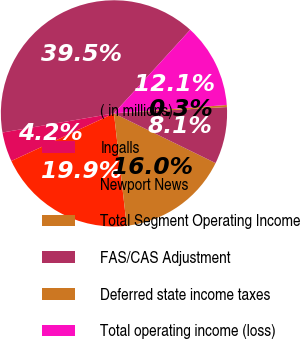Convert chart to OTSL. <chart><loc_0><loc_0><loc_500><loc_500><pie_chart><fcel>( in millions)<fcel>Ingalls<fcel>Newport News<fcel>Total Segment Operating Income<fcel>FAS/CAS Adjustment<fcel>Deferred state income taxes<fcel>Total operating income (loss)<nl><fcel>39.47%<fcel>4.21%<fcel>19.88%<fcel>15.96%<fcel>8.13%<fcel>0.29%<fcel>12.05%<nl></chart> 